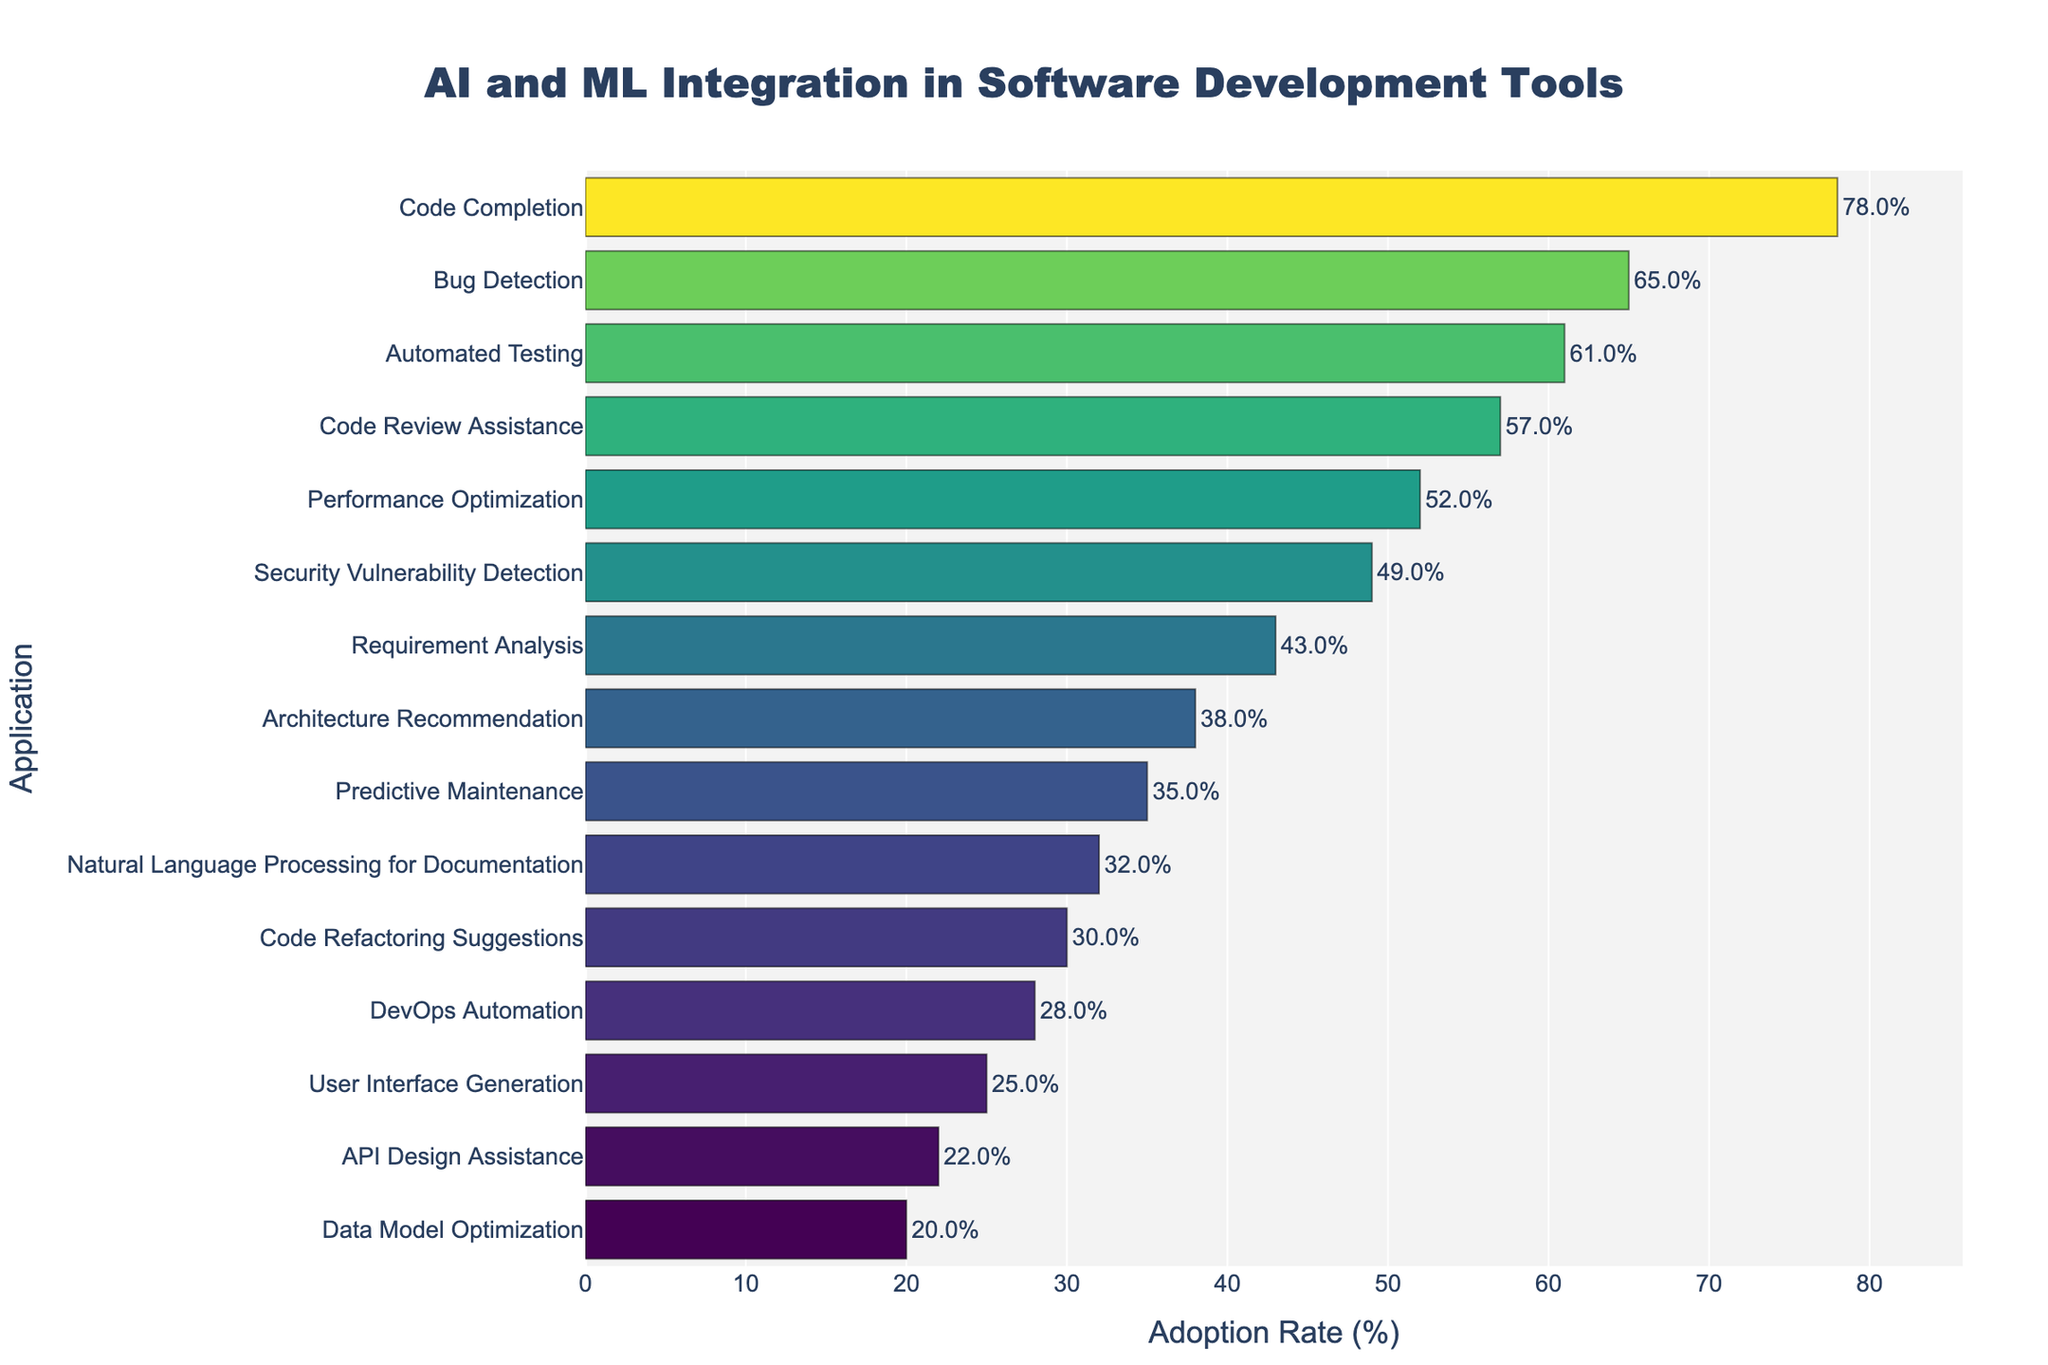Which application has the highest adoption rate for AI and ML integration in software development tools? Look at the bar chart and find the application with the longest bar, which corresponds to the highest adoption rate.
Answer: Code Completion What is the difference in adoption rate between Code Review Assistance and Performance Optimization? Find the adoption rates for both applications on the bar chart (57% for Code Review Assistance and 52% for Performance Optimization) and calculate the difference (57% - 52%).
Answer: 5% Which application has a lower adoption rate, Natural Language Processing for Documentation or Security Vulnerability Detection? Compare the lengths of the bars for Natural Language Processing for Documentation (32%) and Security Vulnerability Detection (49%).
Answer: Natural Language Processing for Documentation What's the average adoption rate of the top three applications? Identify the top three applications (Code Completion 78%, Bug Detection 65%, Automated Testing 61%). Sum their adoption rates (78 + 65 + 61 = 204) and divide by the number of applications (3).
Answer: 68% By how much does the adoption rate for User Interface Generation fall short of the requirement analysis? Locate the adoption rates for User Interface Generation (25%) and Requirement Analysis (43%), and calculate the difference (43% - 25%).
Answer: 18% What is the least adopted application for AI and ML integration in software development tools? Find the shortest bar in the chart, which represents the lowest adoption rate.
Answer: Data Model Optimization How many applications have an adoption rate higher than 50%? Count the number of bars with an adoption rate greater than 50%. These applications are Code Completion (78%), Bug Detection (65%), Automated Testing (61%), Code Review Assistance (57%), and Performance Optimization (52%).
Answer: 5 Which application group shows almost similar adoption rates? Look for applications with bars having nearly the same length. Code Refactoring Suggestions (30%) and Natural Language Processing for Documentation (32%) are close to each other.
Answer: Code Refactoring Suggestions and Natural Language Processing for Documentation What is the sum of the adoption rates for Requirement Analysis and Architecture Recommendation? Find the adoption rates for Requirement Analysis (43%) and Architecture Recommendation (38%), and sum them up (43 + 38).
Answer: 81% 